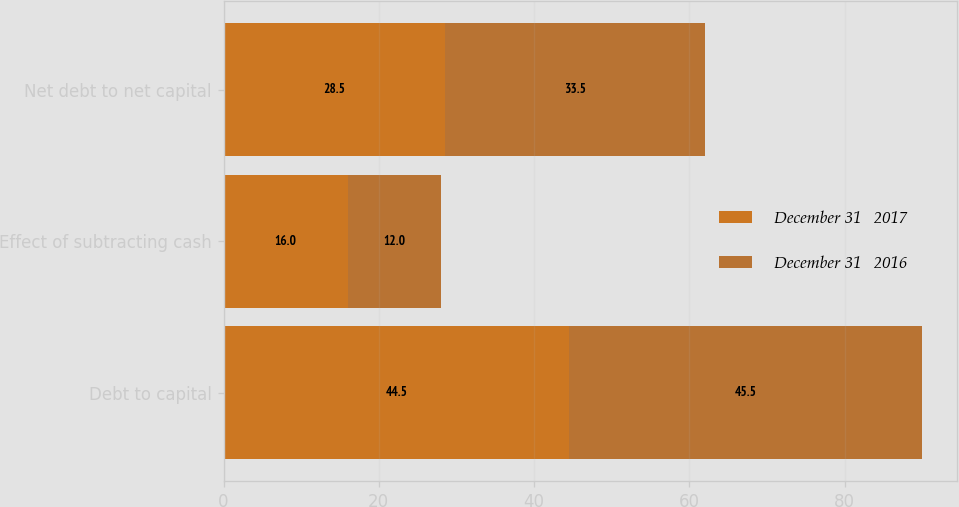<chart> <loc_0><loc_0><loc_500><loc_500><stacked_bar_chart><ecel><fcel>Debt to capital<fcel>Effect of subtracting cash<fcel>Net debt to net capital<nl><fcel>December 31   2017<fcel>44.5<fcel>16<fcel>28.5<nl><fcel>December 31   2016<fcel>45.5<fcel>12<fcel>33.5<nl></chart> 